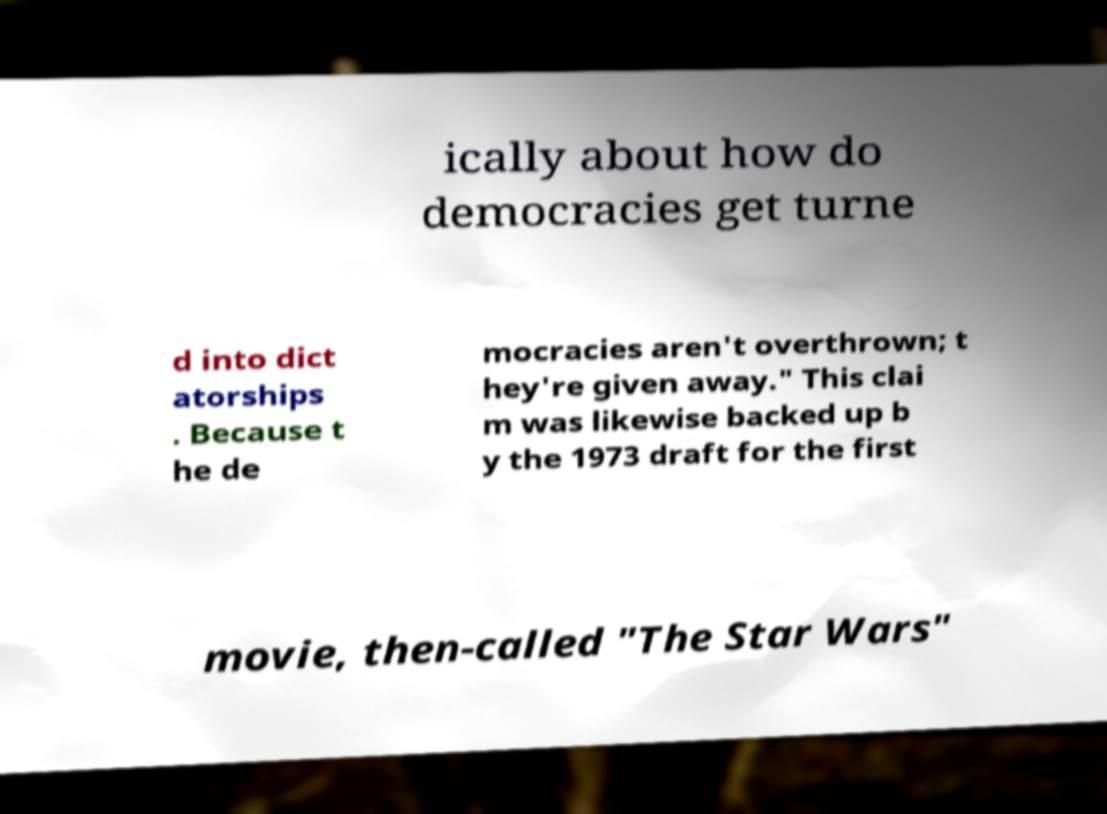Can you accurately transcribe the text from the provided image for me? ically about how do democracies get turne d into dict atorships . Because t he de mocracies aren't overthrown; t hey're given away." This clai m was likewise backed up b y the 1973 draft for the first movie, then-called "The Star Wars" 